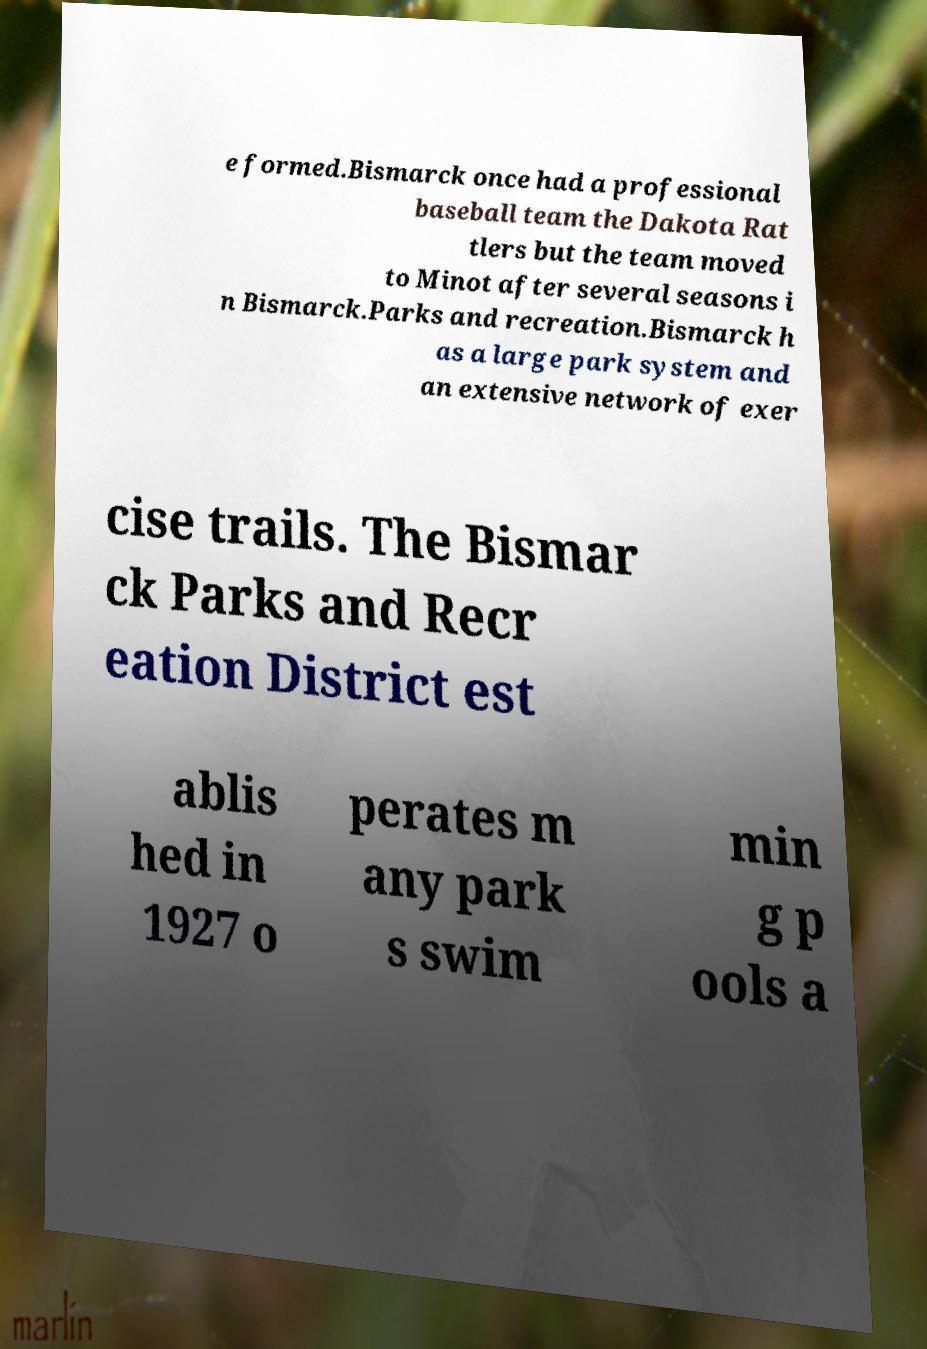Please identify and transcribe the text found in this image. e formed.Bismarck once had a professional baseball team the Dakota Rat tlers but the team moved to Minot after several seasons i n Bismarck.Parks and recreation.Bismarck h as a large park system and an extensive network of exer cise trails. The Bismar ck Parks and Recr eation District est ablis hed in 1927 o perates m any park s swim min g p ools a 